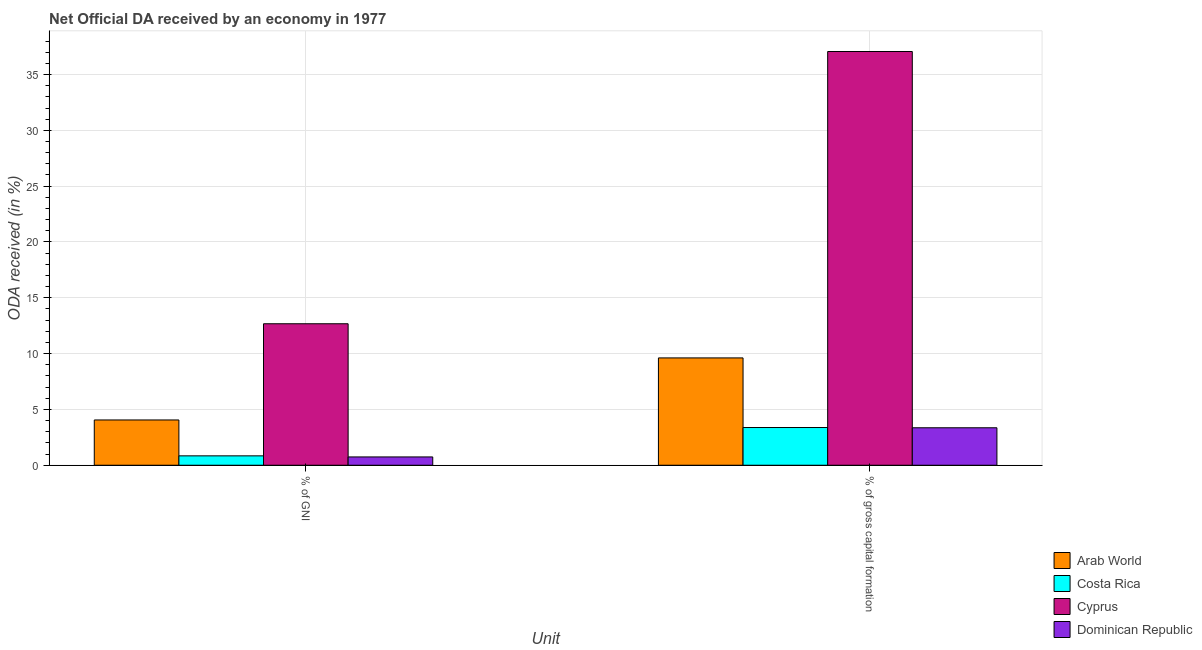How many groups of bars are there?
Offer a very short reply. 2. Are the number of bars per tick equal to the number of legend labels?
Your response must be concise. Yes. How many bars are there on the 2nd tick from the right?
Provide a short and direct response. 4. What is the label of the 1st group of bars from the left?
Your answer should be compact. % of GNI. What is the oda received as percentage of gross capital formation in Costa Rica?
Offer a terse response. 3.38. Across all countries, what is the maximum oda received as percentage of gni?
Give a very brief answer. 12.67. Across all countries, what is the minimum oda received as percentage of gni?
Your response must be concise. 0.74. In which country was the oda received as percentage of gni maximum?
Your response must be concise. Cyprus. In which country was the oda received as percentage of gni minimum?
Provide a short and direct response. Dominican Republic. What is the total oda received as percentage of gni in the graph?
Offer a terse response. 18.32. What is the difference between the oda received as percentage of gross capital formation in Costa Rica and that in Arab World?
Your answer should be very brief. -6.24. What is the difference between the oda received as percentage of gross capital formation in Dominican Republic and the oda received as percentage of gni in Arab World?
Offer a very short reply. -0.7. What is the average oda received as percentage of gni per country?
Ensure brevity in your answer.  4.58. What is the difference between the oda received as percentage of gni and oda received as percentage of gross capital formation in Cyprus?
Ensure brevity in your answer.  -24.39. In how many countries, is the oda received as percentage of gni greater than 25 %?
Your answer should be very brief. 0. What is the ratio of the oda received as percentage of gross capital formation in Cyprus to that in Arab World?
Give a very brief answer. 3.85. Is the oda received as percentage of gni in Dominican Republic less than that in Arab World?
Keep it short and to the point. Yes. What does the 1st bar from the left in % of GNI represents?
Your answer should be compact. Arab World. What does the 3rd bar from the right in % of GNI represents?
Your answer should be compact. Costa Rica. Are all the bars in the graph horizontal?
Provide a succinct answer. No. What is the difference between two consecutive major ticks on the Y-axis?
Your answer should be very brief. 5. Where does the legend appear in the graph?
Keep it short and to the point. Bottom right. How are the legend labels stacked?
Provide a succinct answer. Vertical. What is the title of the graph?
Offer a very short reply. Net Official DA received by an economy in 1977. What is the label or title of the X-axis?
Give a very brief answer. Unit. What is the label or title of the Y-axis?
Offer a very short reply. ODA received (in %). What is the ODA received (in %) of Arab World in % of GNI?
Offer a very short reply. 4.06. What is the ODA received (in %) of Costa Rica in % of GNI?
Make the answer very short. 0.84. What is the ODA received (in %) in Cyprus in % of GNI?
Your response must be concise. 12.67. What is the ODA received (in %) of Dominican Republic in % of GNI?
Keep it short and to the point. 0.74. What is the ODA received (in %) of Arab World in % of gross capital formation?
Offer a terse response. 9.61. What is the ODA received (in %) of Costa Rica in % of gross capital formation?
Provide a short and direct response. 3.38. What is the ODA received (in %) in Cyprus in % of gross capital formation?
Your response must be concise. 37.06. What is the ODA received (in %) of Dominican Republic in % of gross capital formation?
Offer a very short reply. 3.36. Across all Unit, what is the maximum ODA received (in %) in Arab World?
Your answer should be very brief. 9.61. Across all Unit, what is the maximum ODA received (in %) in Costa Rica?
Ensure brevity in your answer.  3.38. Across all Unit, what is the maximum ODA received (in %) of Cyprus?
Your response must be concise. 37.06. Across all Unit, what is the maximum ODA received (in %) in Dominican Republic?
Provide a short and direct response. 3.36. Across all Unit, what is the minimum ODA received (in %) in Arab World?
Offer a terse response. 4.06. Across all Unit, what is the minimum ODA received (in %) in Costa Rica?
Offer a terse response. 0.84. Across all Unit, what is the minimum ODA received (in %) of Cyprus?
Ensure brevity in your answer.  12.67. Across all Unit, what is the minimum ODA received (in %) in Dominican Republic?
Ensure brevity in your answer.  0.74. What is the total ODA received (in %) of Arab World in the graph?
Offer a very short reply. 13.67. What is the total ODA received (in %) in Costa Rica in the graph?
Offer a very short reply. 4.22. What is the total ODA received (in %) in Cyprus in the graph?
Your response must be concise. 49.73. What is the total ODA received (in %) of Dominican Republic in the graph?
Offer a very short reply. 4.1. What is the difference between the ODA received (in %) of Arab World in % of GNI and that in % of gross capital formation?
Your answer should be very brief. -5.56. What is the difference between the ODA received (in %) in Costa Rica in % of GNI and that in % of gross capital formation?
Your answer should be very brief. -2.54. What is the difference between the ODA received (in %) in Cyprus in % of GNI and that in % of gross capital formation?
Offer a very short reply. -24.39. What is the difference between the ODA received (in %) in Dominican Republic in % of GNI and that in % of gross capital formation?
Make the answer very short. -2.61. What is the difference between the ODA received (in %) of Arab World in % of GNI and the ODA received (in %) of Costa Rica in % of gross capital formation?
Give a very brief answer. 0.68. What is the difference between the ODA received (in %) in Arab World in % of GNI and the ODA received (in %) in Cyprus in % of gross capital formation?
Offer a terse response. -33.01. What is the difference between the ODA received (in %) in Arab World in % of GNI and the ODA received (in %) in Dominican Republic in % of gross capital formation?
Offer a very short reply. 0.7. What is the difference between the ODA received (in %) in Costa Rica in % of GNI and the ODA received (in %) in Cyprus in % of gross capital formation?
Provide a short and direct response. -36.22. What is the difference between the ODA received (in %) of Costa Rica in % of GNI and the ODA received (in %) of Dominican Republic in % of gross capital formation?
Make the answer very short. -2.52. What is the difference between the ODA received (in %) of Cyprus in % of GNI and the ODA received (in %) of Dominican Republic in % of gross capital formation?
Make the answer very short. 9.32. What is the average ODA received (in %) of Arab World per Unit?
Your answer should be very brief. 6.83. What is the average ODA received (in %) in Costa Rica per Unit?
Provide a succinct answer. 2.11. What is the average ODA received (in %) of Cyprus per Unit?
Offer a very short reply. 24.87. What is the average ODA received (in %) in Dominican Republic per Unit?
Give a very brief answer. 2.05. What is the difference between the ODA received (in %) in Arab World and ODA received (in %) in Costa Rica in % of GNI?
Provide a succinct answer. 3.21. What is the difference between the ODA received (in %) in Arab World and ODA received (in %) in Cyprus in % of GNI?
Make the answer very short. -8.62. What is the difference between the ODA received (in %) of Arab World and ODA received (in %) of Dominican Republic in % of GNI?
Offer a very short reply. 3.31. What is the difference between the ODA received (in %) in Costa Rica and ODA received (in %) in Cyprus in % of GNI?
Offer a very short reply. -11.83. What is the difference between the ODA received (in %) in Costa Rica and ODA received (in %) in Dominican Republic in % of GNI?
Keep it short and to the point. 0.1. What is the difference between the ODA received (in %) in Cyprus and ODA received (in %) in Dominican Republic in % of GNI?
Make the answer very short. 11.93. What is the difference between the ODA received (in %) of Arab World and ODA received (in %) of Costa Rica in % of gross capital formation?
Provide a succinct answer. 6.24. What is the difference between the ODA received (in %) in Arab World and ODA received (in %) in Cyprus in % of gross capital formation?
Provide a succinct answer. -27.45. What is the difference between the ODA received (in %) in Arab World and ODA received (in %) in Dominican Republic in % of gross capital formation?
Provide a succinct answer. 6.26. What is the difference between the ODA received (in %) of Costa Rica and ODA received (in %) of Cyprus in % of gross capital formation?
Keep it short and to the point. -33.68. What is the difference between the ODA received (in %) of Costa Rica and ODA received (in %) of Dominican Republic in % of gross capital formation?
Offer a very short reply. 0.02. What is the difference between the ODA received (in %) in Cyprus and ODA received (in %) in Dominican Republic in % of gross capital formation?
Your answer should be very brief. 33.7. What is the ratio of the ODA received (in %) in Arab World in % of GNI to that in % of gross capital formation?
Your response must be concise. 0.42. What is the ratio of the ODA received (in %) of Costa Rica in % of GNI to that in % of gross capital formation?
Keep it short and to the point. 0.25. What is the ratio of the ODA received (in %) in Cyprus in % of GNI to that in % of gross capital formation?
Your answer should be very brief. 0.34. What is the ratio of the ODA received (in %) of Dominican Republic in % of GNI to that in % of gross capital formation?
Your response must be concise. 0.22. What is the difference between the highest and the second highest ODA received (in %) in Arab World?
Your answer should be compact. 5.56. What is the difference between the highest and the second highest ODA received (in %) in Costa Rica?
Ensure brevity in your answer.  2.54. What is the difference between the highest and the second highest ODA received (in %) of Cyprus?
Provide a short and direct response. 24.39. What is the difference between the highest and the second highest ODA received (in %) in Dominican Republic?
Offer a terse response. 2.61. What is the difference between the highest and the lowest ODA received (in %) in Arab World?
Your answer should be very brief. 5.56. What is the difference between the highest and the lowest ODA received (in %) of Costa Rica?
Make the answer very short. 2.54. What is the difference between the highest and the lowest ODA received (in %) in Cyprus?
Your response must be concise. 24.39. What is the difference between the highest and the lowest ODA received (in %) in Dominican Republic?
Your answer should be very brief. 2.61. 